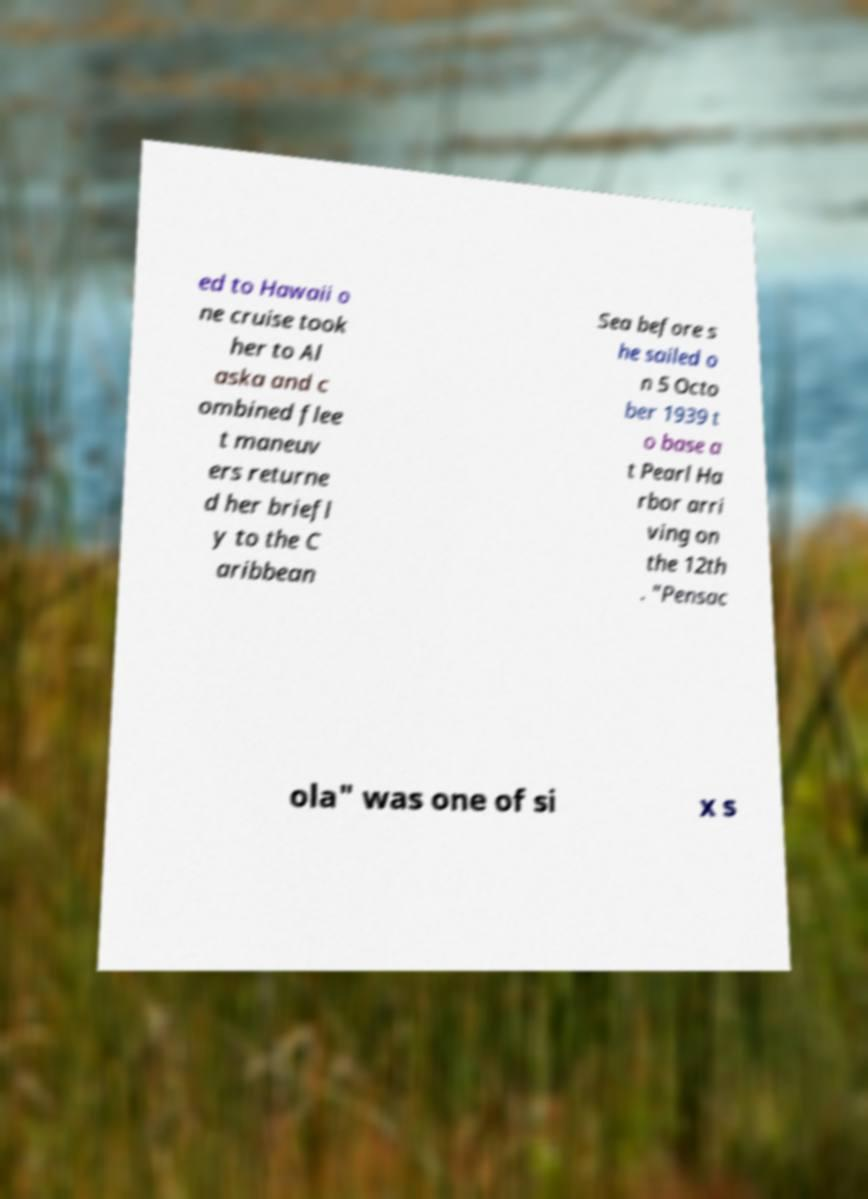For documentation purposes, I need the text within this image transcribed. Could you provide that? ed to Hawaii o ne cruise took her to Al aska and c ombined flee t maneuv ers returne d her briefl y to the C aribbean Sea before s he sailed o n 5 Octo ber 1939 t o base a t Pearl Ha rbor arri ving on the 12th . "Pensac ola" was one of si x s 